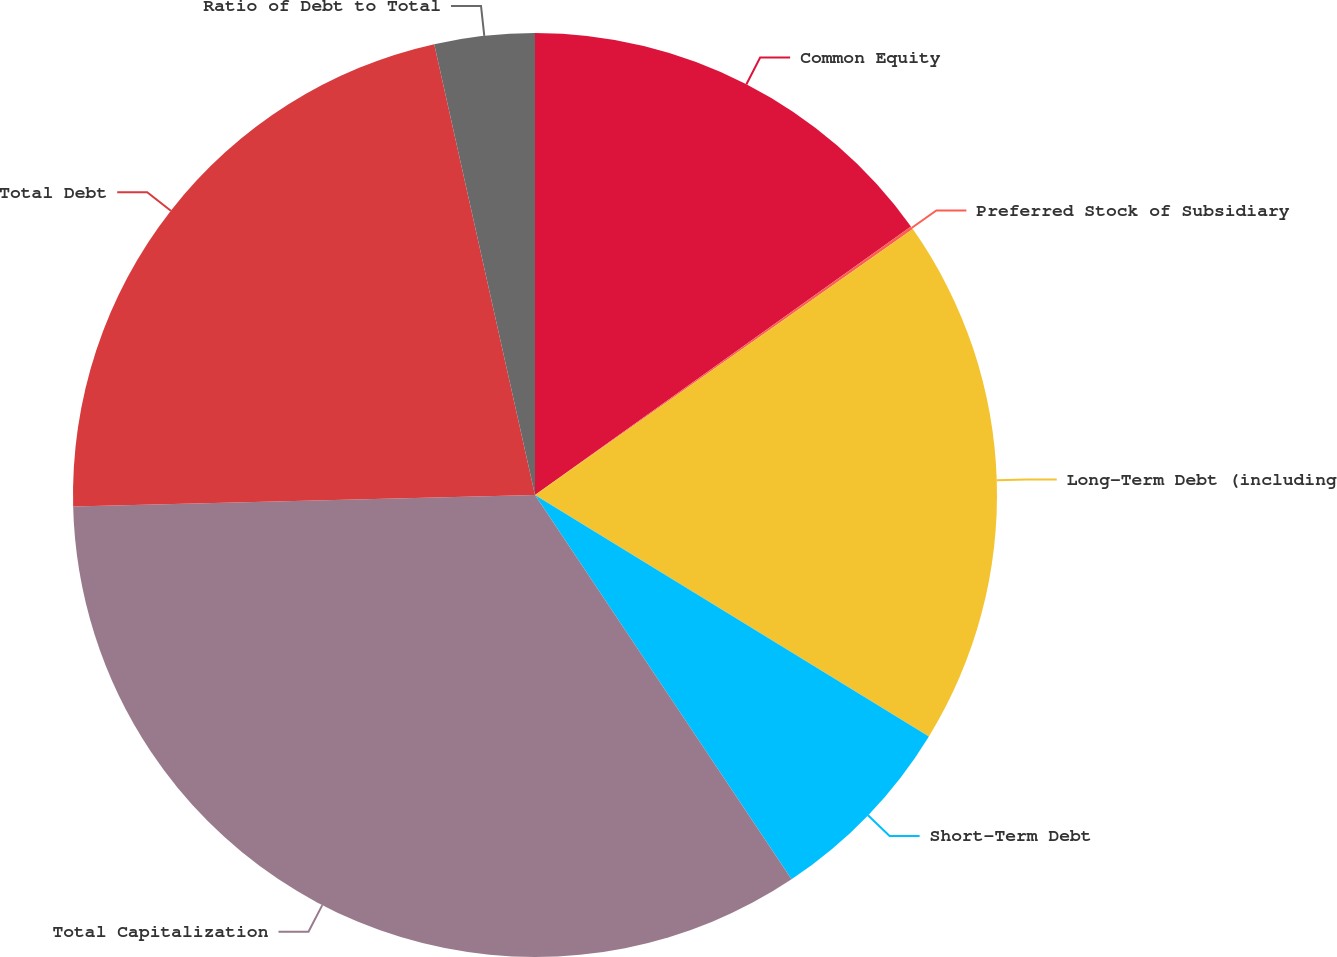<chart> <loc_0><loc_0><loc_500><loc_500><pie_chart><fcel>Common Equity<fcel>Preferred Stock of Subsidiary<fcel>Long-Term Debt (including<fcel>Short-Term Debt<fcel>Total Capitalization<fcel>Total Debt<fcel>Ratio of Debt to Total<nl><fcel>15.13%<fcel>0.11%<fcel>18.51%<fcel>6.88%<fcel>33.97%<fcel>21.9%<fcel>3.5%<nl></chart> 